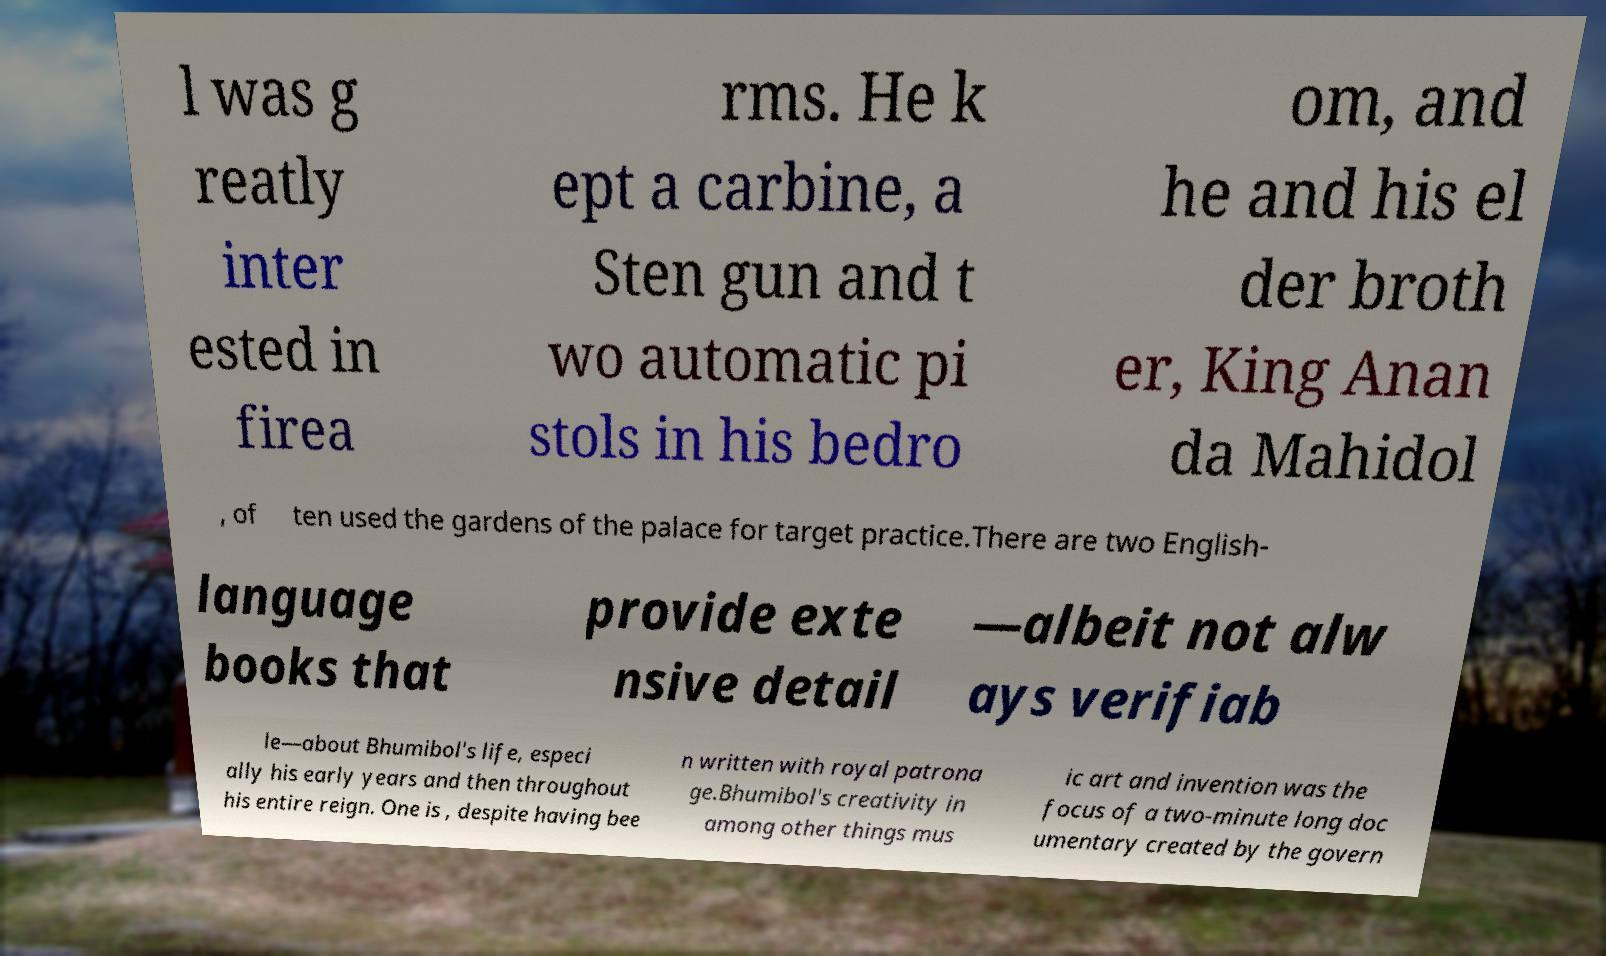Could you assist in decoding the text presented in this image and type it out clearly? l was g reatly inter ested in firea rms. He k ept a carbine, a Sten gun and t wo automatic pi stols in his bedro om, and he and his el der broth er, King Anan da Mahidol , of ten used the gardens of the palace for target practice.There are two English- language books that provide exte nsive detail —albeit not alw ays verifiab le—about Bhumibol's life, especi ally his early years and then throughout his entire reign. One is , despite having bee n written with royal patrona ge.Bhumibol's creativity in among other things mus ic art and invention was the focus of a two-minute long doc umentary created by the govern 